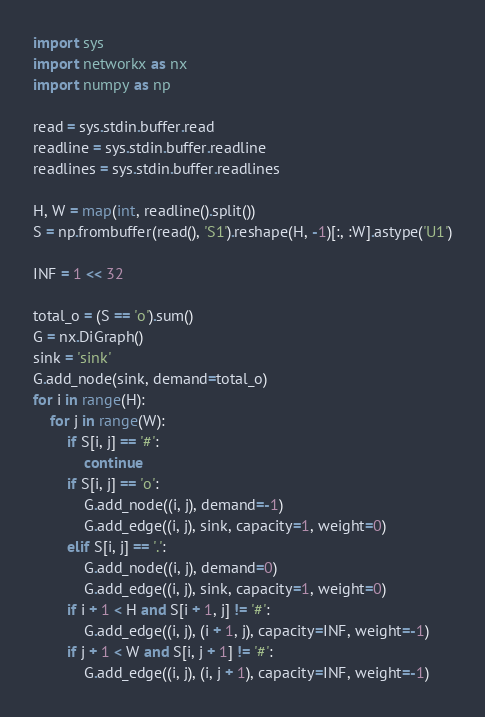Convert code to text. <code><loc_0><loc_0><loc_500><loc_500><_Python_>import sys
import networkx as nx
import numpy as np

read = sys.stdin.buffer.read
readline = sys.stdin.buffer.readline
readlines = sys.stdin.buffer.readlines

H, W = map(int, readline().split())
S = np.frombuffer(read(), 'S1').reshape(H, -1)[:, :W].astype('U1')

INF = 1 << 32

total_o = (S == 'o').sum()
G = nx.DiGraph()
sink = 'sink'
G.add_node(sink, demand=total_o)
for i in range(H):
    for j in range(W):
        if S[i, j] == '#':
            continue
        if S[i, j] == 'o':
            G.add_node((i, j), demand=-1)
            G.add_edge((i, j), sink, capacity=1, weight=0)
        elif S[i, j] == '.':
            G.add_node((i, j), demand=0)
            G.add_edge((i, j), sink, capacity=1, weight=0)
        if i + 1 < H and S[i + 1, j] != '#':
            G.add_edge((i, j), (i + 1, j), capacity=INF, weight=-1)
        if j + 1 < W and S[i, j + 1] != '#':
            G.add_edge((i, j), (i, j + 1), capacity=INF, weight=-1)
</code> 